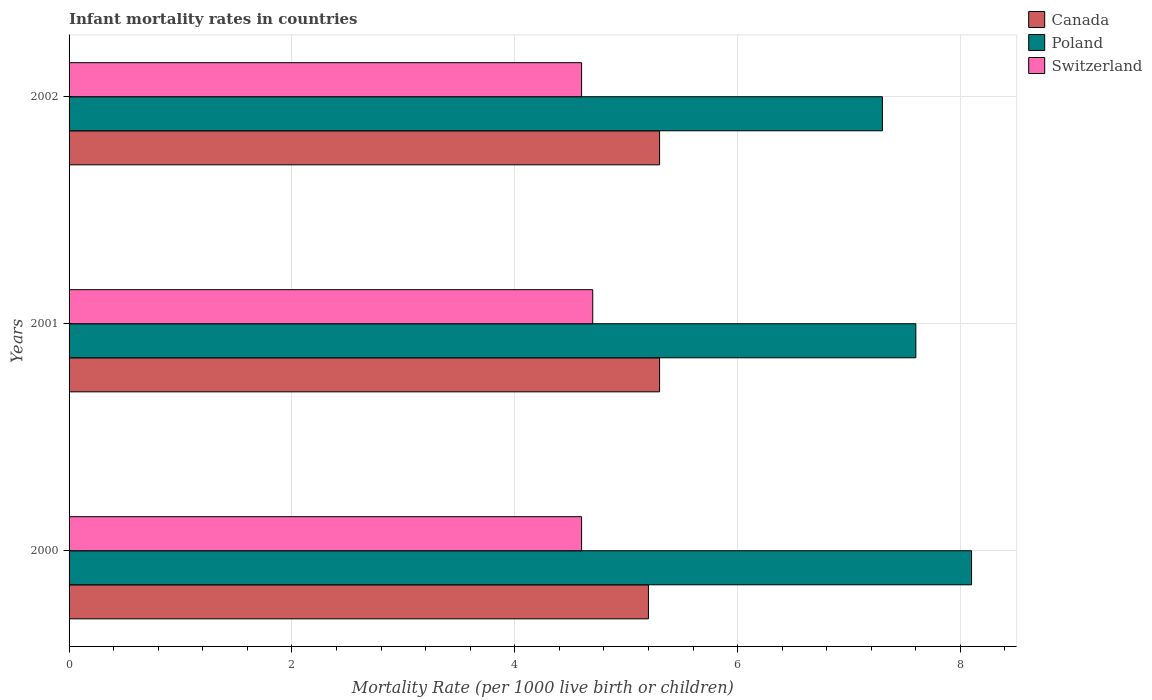How many different coloured bars are there?
Provide a succinct answer. 3. Are the number of bars per tick equal to the number of legend labels?
Offer a terse response. Yes. Are the number of bars on each tick of the Y-axis equal?
Your response must be concise. Yes. In how many cases, is the number of bars for a given year not equal to the number of legend labels?
Make the answer very short. 0. Across all years, what is the minimum infant mortality rate in Poland?
Ensure brevity in your answer.  7.3. In which year was the infant mortality rate in Canada maximum?
Offer a very short reply. 2001. What is the total infant mortality rate in Canada in the graph?
Offer a very short reply. 15.8. What is the difference between the infant mortality rate in Switzerland in 2000 and that in 2001?
Provide a succinct answer. -0.1. What is the difference between the infant mortality rate in Switzerland in 2000 and the infant mortality rate in Poland in 2002?
Your response must be concise. -2.7. What is the average infant mortality rate in Switzerland per year?
Provide a short and direct response. 4.63. In the year 2001, what is the difference between the infant mortality rate in Canada and infant mortality rate in Switzerland?
Provide a short and direct response. 0.6. What is the ratio of the infant mortality rate in Poland in 2000 to that in 2001?
Keep it short and to the point. 1.07. Is the difference between the infant mortality rate in Canada in 2000 and 2001 greater than the difference between the infant mortality rate in Switzerland in 2000 and 2001?
Make the answer very short. Yes. What is the difference between the highest and the second highest infant mortality rate in Canada?
Ensure brevity in your answer.  0. What is the difference between the highest and the lowest infant mortality rate in Poland?
Your answer should be compact. 0.8. What does the 1st bar from the bottom in 2000 represents?
Ensure brevity in your answer.  Canada. Is it the case that in every year, the sum of the infant mortality rate in Switzerland and infant mortality rate in Poland is greater than the infant mortality rate in Canada?
Give a very brief answer. Yes. How many bars are there?
Keep it short and to the point. 9. Are all the bars in the graph horizontal?
Provide a succinct answer. Yes. How many years are there in the graph?
Ensure brevity in your answer.  3. What is the difference between two consecutive major ticks on the X-axis?
Your answer should be compact. 2. Are the values on the major ticks of X-axis written in scientific E-notation?
Make the answer very short. No. Does the graph contain any zero values?
Make the answer very short. No. Does the graph contain grids?
Keep it short and to the point. Yes. What is the title of the graph?
Make the answer very short. Infant mortality rates in countries. Does "Ghana" appear as one of the legend labels in the graph?
Your answer should be very brief. No. What is the label or title of the X-axis?
Ensure brevity in your answer.  Mortality Rate (per 1000 live birth or children). What is the label or title of the Y-axis?
Give a very brief answer. Years. What is the Mortality Rate (per 1000 live birth or children) in Poland in 2000?
Give a very brief answer. 8.1. What is the Mortality Rate (per 1000 live birth or children) of Canada in 2001?
Your response must be concise. 5.3. What is the Mortality Rate (per 1000 live birth or children) in Poland in 2001?
Keep it short and to the point. 7.6. Across all years, what is the maximum Mortality Rate (per 1000 live birth or children) of Canada?
Make the answer very short. 5.3. Across all years, what is the maximum Mortality Rate (per 1000 live birth or children) in Switzerland?
Provide a short and direct response. 4.7. Across all years, what is the minimum Mortality Rate (per 1000 live birth or children) in Poland?
Your response must be concise. 7.3. What is the total Mortality Rate (per 1000 live birth or children) of Poland in the graph?
Your answer should be compact. 23. What is the difference between the Mortality Rate (per 1000 live birth or children) in Canada in 2000 and that in 2001?
Ensure brevity in your answer.  -0.1. What is the difference between the Mortality Rate (per 1000 live birth or children) in Canada in 2000 and that in 2002?
Your response must be concise. -0.1. What is the difference between the Mortality Rate (per 1000 live birth or children) of Poland in 2000 and that in 2002?
Ensure brevity in your answer.  0.8. What is the difference between the Mortality Rate (per 1000 live birth or children) of Poland in 2001 and that in 2002?
Offer a very short reply. 0.3. What is the difference between the Mortality Rate (per 1000 live birth or children) of Canada in 2000 and the Mortality Rate (per 1000 live birth or children) of Switzerland in 2001?
Offer a terse response. 0.5. What is the difference between the Mortality Rate (per 1000 live birth or children) of Canada in 2000 and the Mortality Rate (per 1000 live birth or children) of Poland in 2002?
Offer a very short reply. -2.1. What is the difference between the Mortality Rate (per 1000 live birth or children) of Poland in 2000 and the Mortality Rate (per 1000 live birth or children) of Switzerland in 2002?
Your answer should be compact. 3.5. What is the difference between the Mortality Rate (per 1000 live birth or children) in Canada in 2001 and the Mortality Rate (per 1000 live birth or children) in Switzerland in 2002?
Your answer should be very brief. 0.7. What is the average Mortality Rate (per 1000 live birth or children) of Canada per year?
Provide a short and direct response. 5.27. What is the average Mortality Rate (per 1000 live birth or children) of Poland per year?
Your answer should be compact. 7.67. What is the average Mortality Rate (per 1000 live birth or children) in Switzerland per year?
Offer a terse response. 4.63. In the year 2000, what is the difference between the Mortality Rate (per 1000 live birth or children) of Canada and Mortality Rate (per 1000 live birth or children) of Poland?
Ensure brevity in your answer.  -2.9. In the year 2000, what is the difference between the Mortality Rate (per 1000 live birth or children) of Canada and Mortality Rate (per 1000 live birth or children) of Switzerland?
Provide a short and direct response. 0.6. In the year 2001, what is the difference between the Mortality Rate (per 1000 live birth or children) in Canada and Mortality Rate (per 1000 live birth or children) in Poland?
Your answer should be very brief. -2.3. In the year 2001, what is the difference between the Mortality Rate (per 1000 live birth or children) in Canada and Mortality Rate (per 1000 live birth or children) in Switzerland?
Your answer should be compact. 0.6. In the year 2002, what is the difference between the Mortality Rate (per 1000 live birth or children) in Canada and Mortality Rate (per 1000 live birth or children) in Poland?
Provide a short and direct response. -2. In the year 2002, what is the difference between the Mortality Rate (per 1000 live birth or children) in Canada and Mortality Rate (per 1000 live birth or children) in Switzerland?
Your response must be concise. 0.7. What is the ratio of the Mortality Rate (per 1000 live birth or children) in Canada in 2000 to that in 2001?
Provide a short and direct response. 0.98. What is the ratio of the Mortality Rate (per 1000 live birth or children) in Poland in 2000 to that in 2001?
Provide a succinct answer. 1.07. What is the ratio of the Mortality Rate (per 1000 live birth or children) of Switzerland in 2000 to that in 2001?
Make the answer very short. 0.98. What is the ratio of the Mortality Rate (per 1000 live birth or children) in Canada in 2000 to that in 2002?
Keep it short and to the point. 0.98. What is the ratio of the Mortality Rate (per 1000 live birth or children) in Poland in 2000 to that in 2002?
Provide a succinct answer. 1.11. What is the ratio of the Mortality Rate (per 1000 live birth or children) in Poland in 2001 to that in 2002?
Your response must be concise. 1.04. What is the ratio of the Mortality Rate (per 1000 live birth or children) in Switzerland in 2001 to that in 2002?
Keep it short and to the point. 1.02. What is the difference between the highest and the second highest Mortality Rate (per 1000 live birth or children) of Canada?
Your response must be concise. 0. What is the difference between the highest and the second highest Mortality Rate (per 1000 live birth or children) in Poland?
Give a very brief answer. 0.5. What is the difference between the highest and the second highest Mortality Rate (per 1000 live birth or children) of Switzerland?
Ensure brevity in your answer.  0.1. What is the difference between the highest and the lowest Mortality Rate (per 1000 live birth or children) of Canada?
Keep it short and to the point. 0.1. 